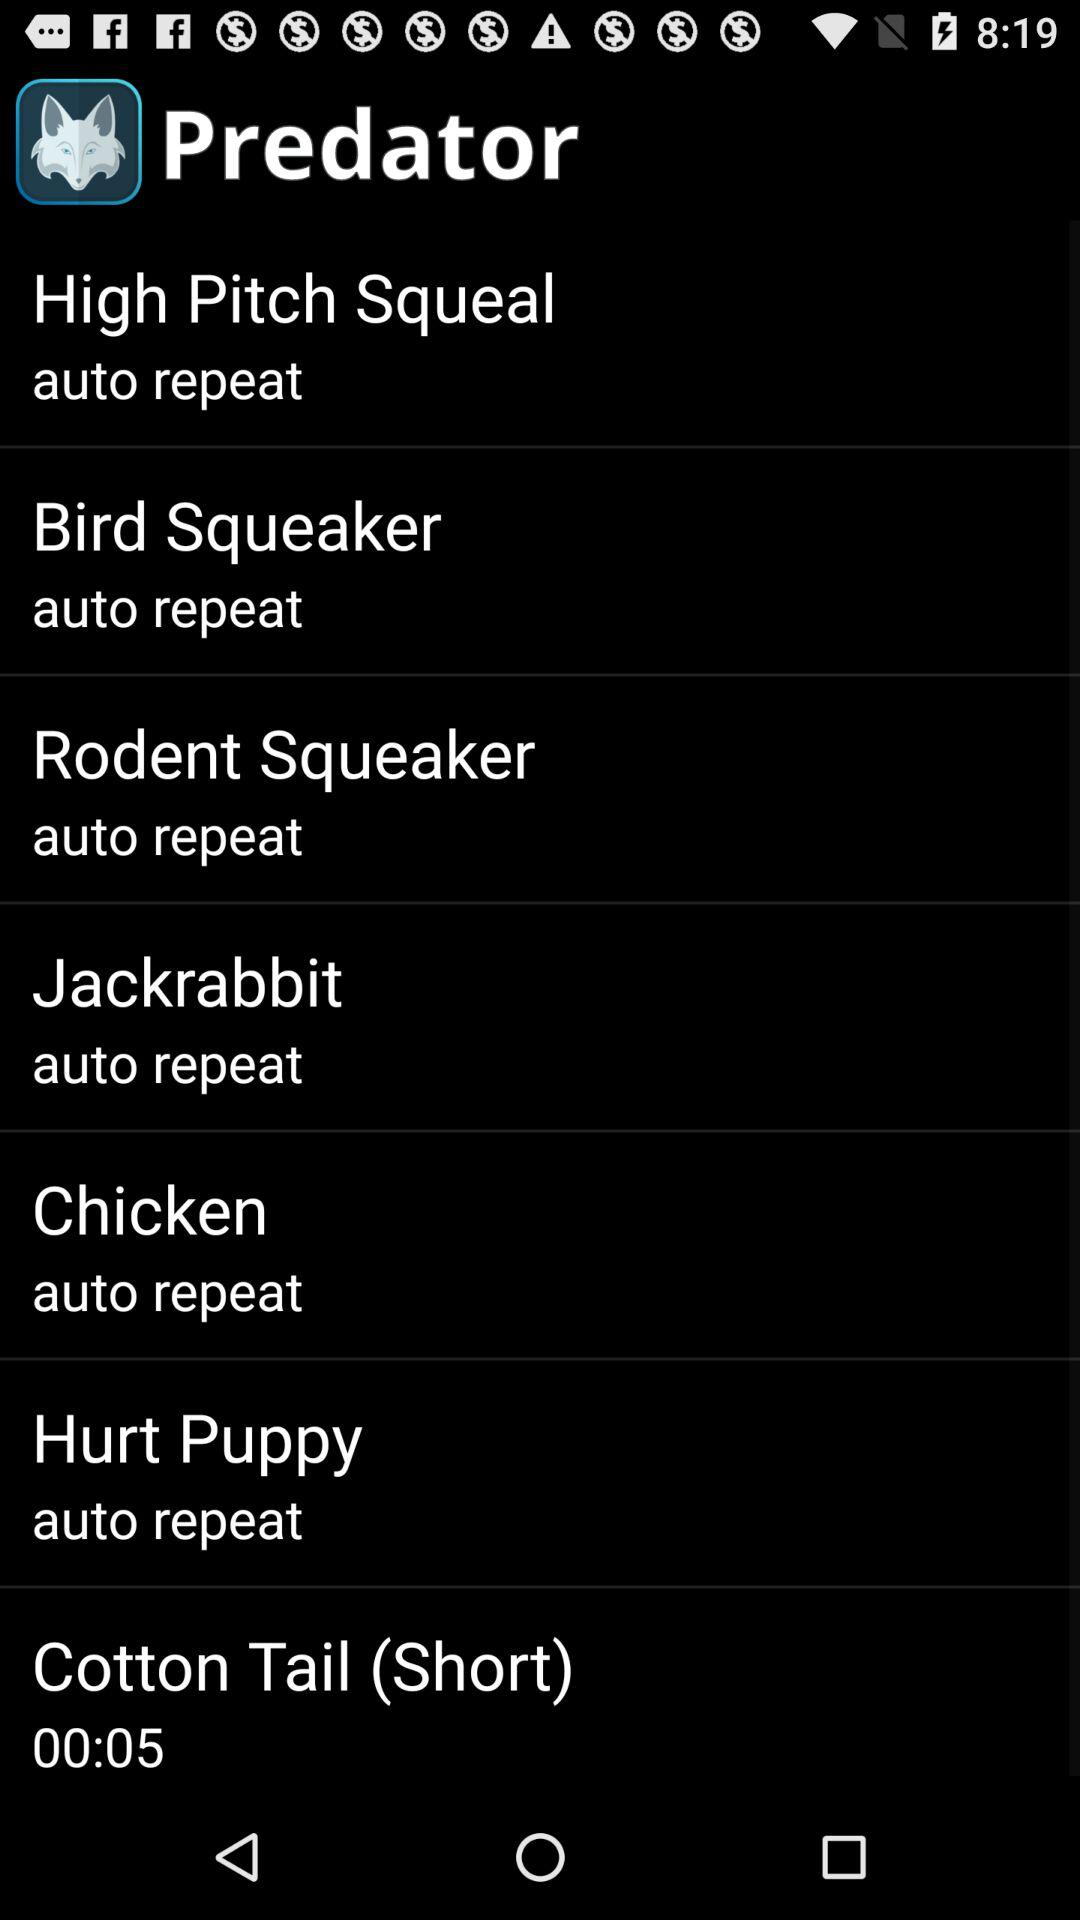What is the app name? The app name is "Predator". 